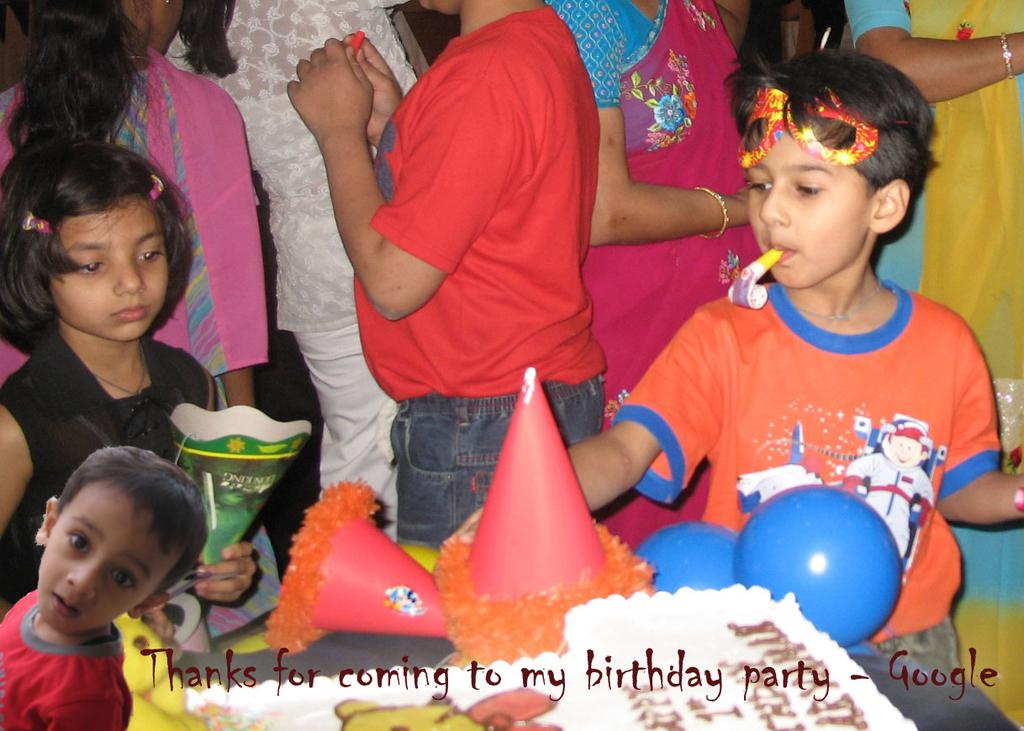What can be seen in front of the table in the image? There are kids in front of the table in the image. What is on top of the table? There is a cake and balloons on the table. What else is on the table besides the cake and balloons? There are caps on the table. Can you describe the people behind the kids? There are other people behind the kids in the image. How many beds are visible in the image? There are no beds visible in the image. What type of ant can be seen crawling on the cake? There are no ants present in the image, let alone crawling on the cake. 